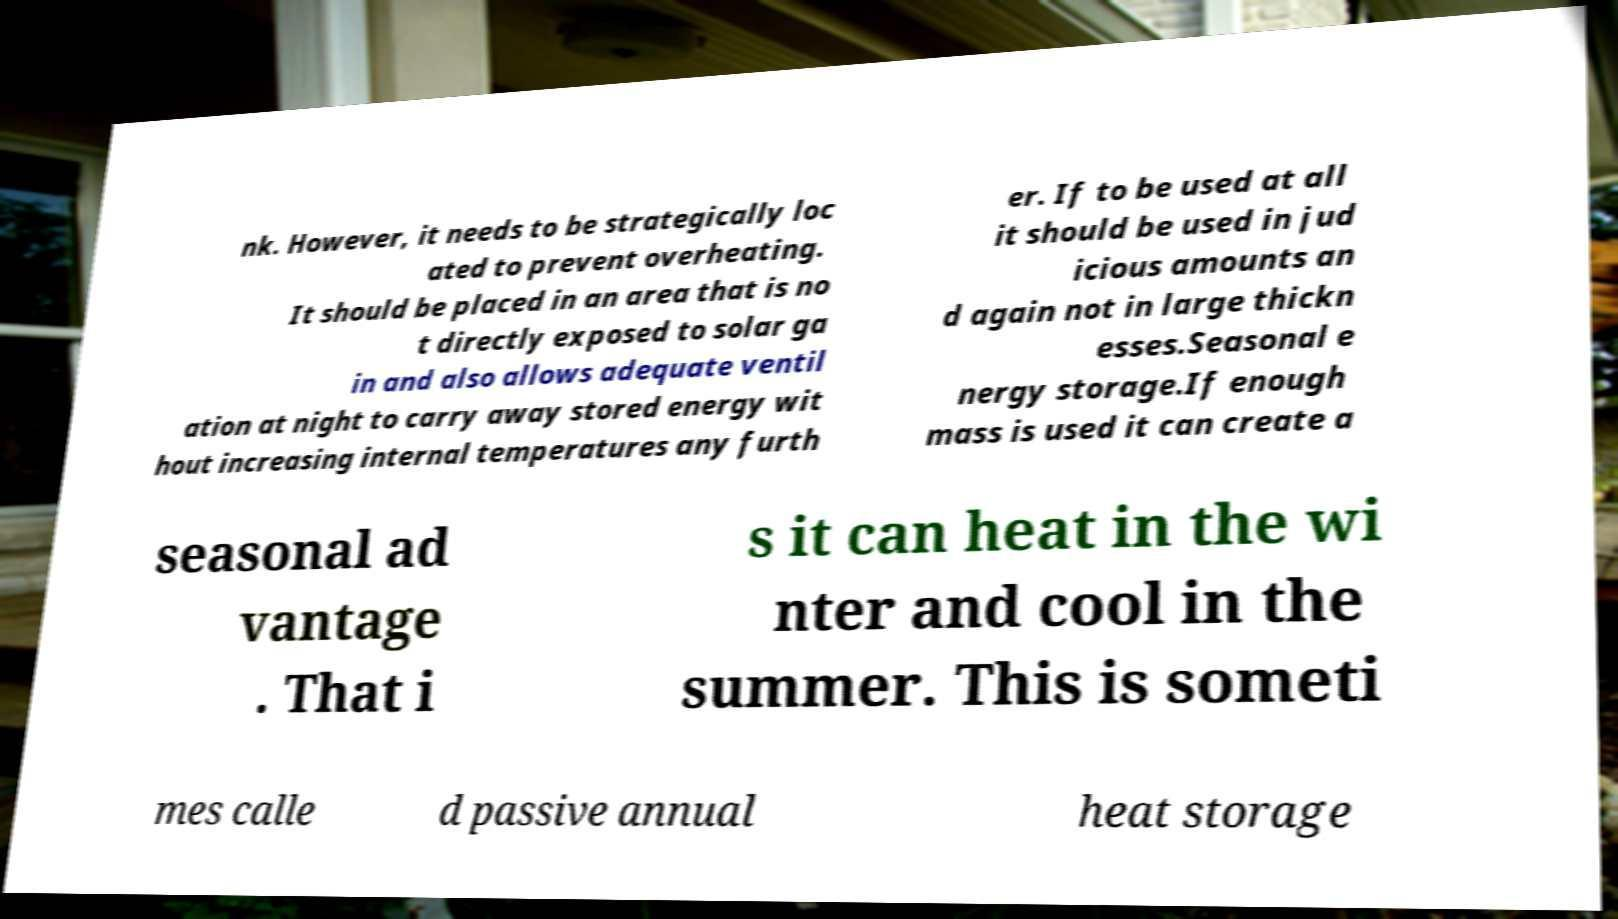Could you extract and type out the text from this image? nk. However, it needs to be strategically loc ated to prevent overheating. It should be placed in an area that is no t directly exposed to solar ga in and also allows adequate ventil ation at night to carry away stored energy wit hout increasing internal temperatures any furth er. If to be used at all it should be used in jud icious amounts an d again not in large thickn esses.Seasonal e nergy storage.If enough mass is used it can create a seasonal ad vantage . That i s it can heat in the wi nter and cool in the summer. This is someti mes calle d passive annual heat storage 